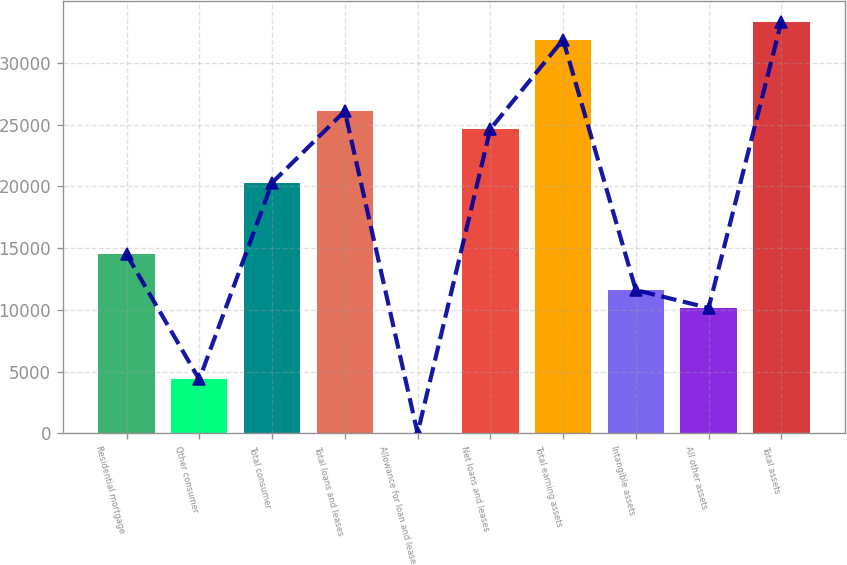Convert chart. <chart><loc_0><loc_0><loc_500><loc_500><bar_chart><fcel>Residential mortgage<fcel>Other consumer<fcel>Total consumer<fcel>Total loans and leases<fcel>Allowance for loan and lease<fcel>Net loans and leases<fcel>Total earning assets<fcel>Intangible assets<fcel>All other assets<fcel>Total assets<nl><fcel>14494<fcel>4353.8<fcel>20288.4<fcel>26082.8<fcel>8<fcel>24634.2<fcel>31877.2<fcel>11596.8<fcel>10148.2<fcel>33325.8<nl></chart> 